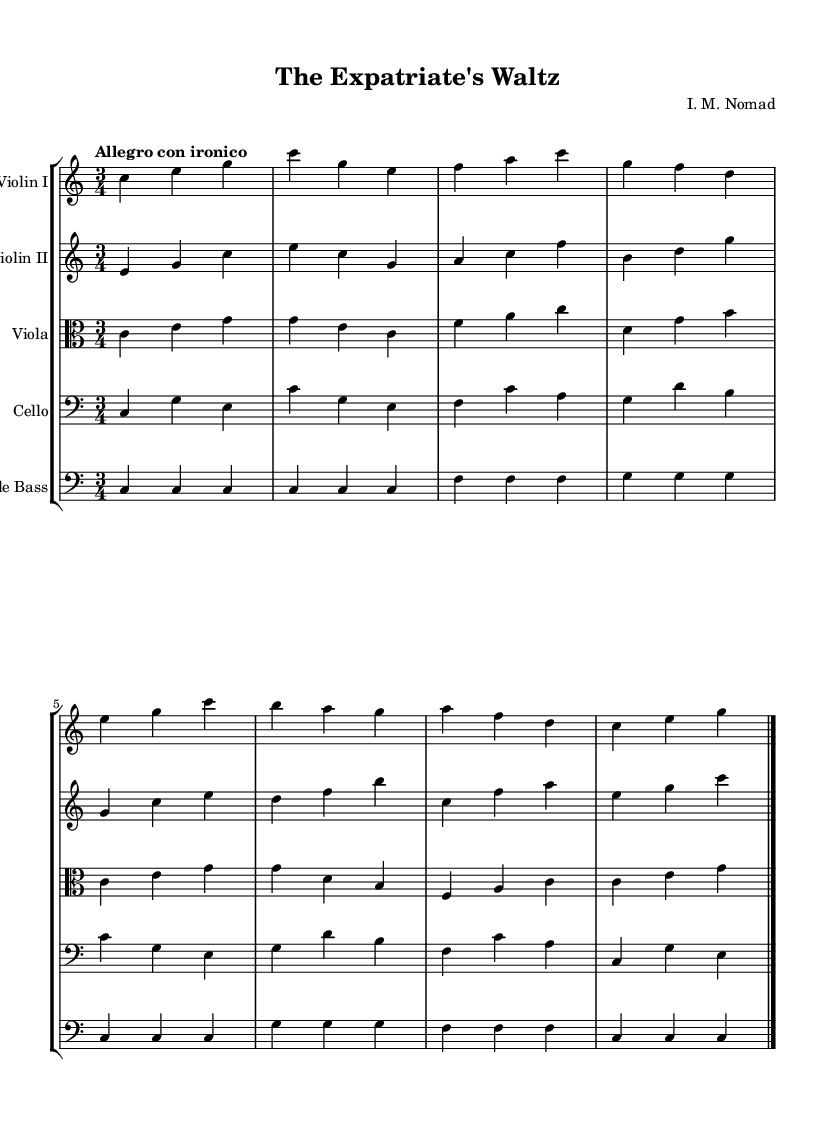What is the key signature of this music? The key signature is C major, which has no sharps or flats.
Answer: C major What is the time signature of this piece? The time signature is indicated at the beginning of the score, appearing as three beats per measure, hence it is 3/4.
Answer: 3/4 What is the tempo marking for this symphony? The tempo marking states "Allegro con ironico," indicating a fast pace with an ironic twist.
Answer: Allegro con ironico How many staves are present in this score? Upon examining the score, there are five individual staves, each representing a different instrument.
Answer: Five What is the instrumentation of this symphony? The score includes Violin I, Violin II, Viola, Cello, and Double Bass, making up the string section of the orchestra.
Answer: String section Which instrument plays the lowest pitch in this score? The Double Bass is notated in the lowest staff and usually produces the lowest pitch of the string instruments, confirming its role in the score.
Answer: Double Bass Which part has the highest pitch? The highest pitch is typically found in the Violin I part, which is notated with the highest staff and has the highest note values.
Answer: Violin I 